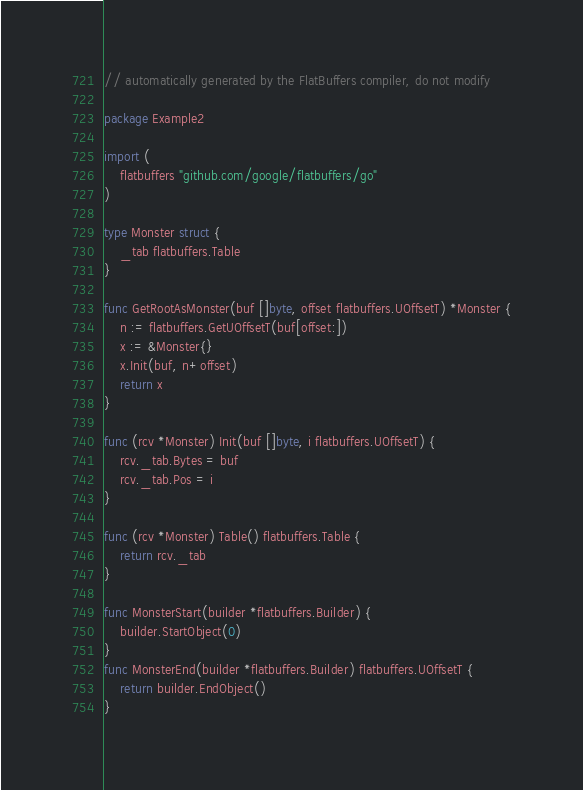<code> <loc_0><loc_0><loc_500><loc_500><_Go_>// automatically generated by the FlatBuffers compiler, do not modify

package Example2

import (
	flatbuffers "github.com/google/flatbuffers/go"
)

type Monster struct {
	_tab flatbuffers.Table
}

func GetRootAsMonster(buf []byte, offset flatbuffers.UOffsetT) *Monster {
	n := flatbuffers.GetUOffsetT(buf[offset:])
	x := &Monster{}
	x.Init(buf, n+offset)
	return x
}

func (rcv *Monster) Init(buf []byte, i flatbuffers.UOffsetT) {
	rcv._tab.Bytes = buf
	rcv._tab.Pos = i
}

func (rcv *Monster) Table() flatbuffers.Table {
	return rcv._tab
}

func MonsterStart(builder *flatbuffers.Builder) {
	builder.StartObject(0)
}
func MonsterEnd(builder *flatbuffers.Builder) flatbuffers.UOffsetT {
	return builder.EndObject()
}
</code> 